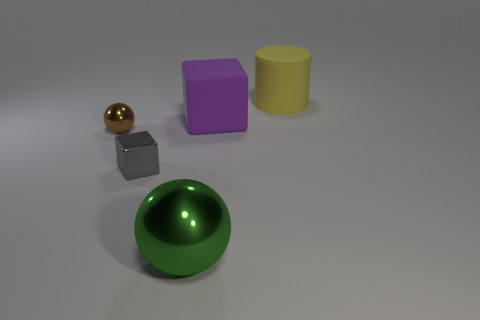Add 4 tiny balls. How many objects exist? 9 Subtract all blocks. How many objects are left? 3 Add 2 green metal objects. How many green metal objects exist? 3 Subtract 0 purple cylinders. How many objects are left? 5 Subtract all small blue matte cubes. Subtract all large yellow objects. How many objects are left? 4 Add 1 small spheres. How many small spheres are left? 2 